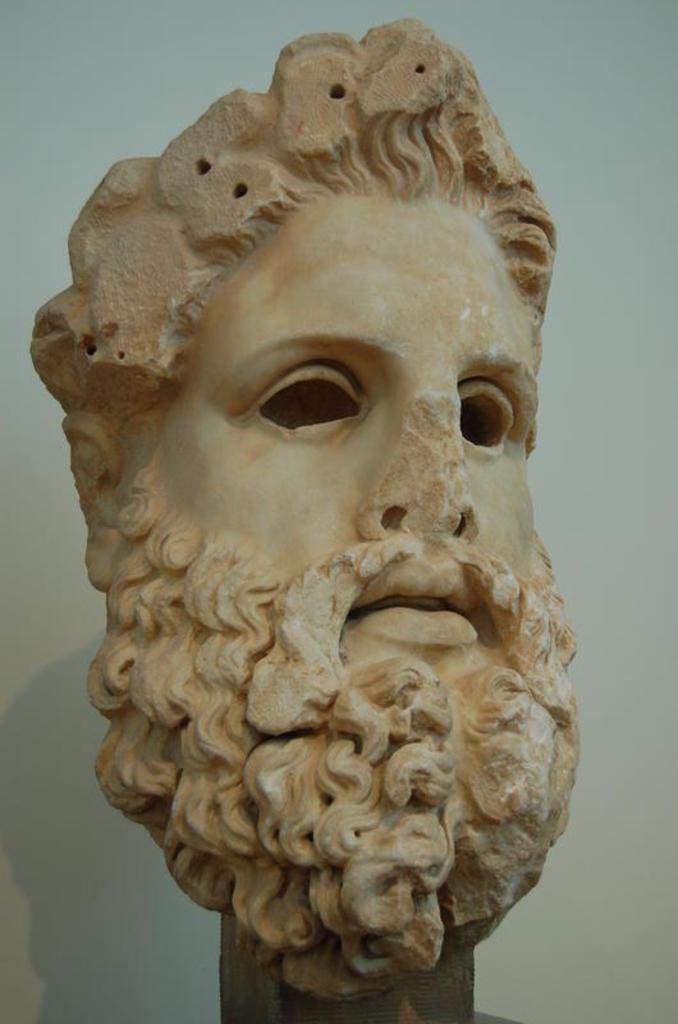Please provide a concise description of this image. In this image there is a sculpture of a man who has a beard. 